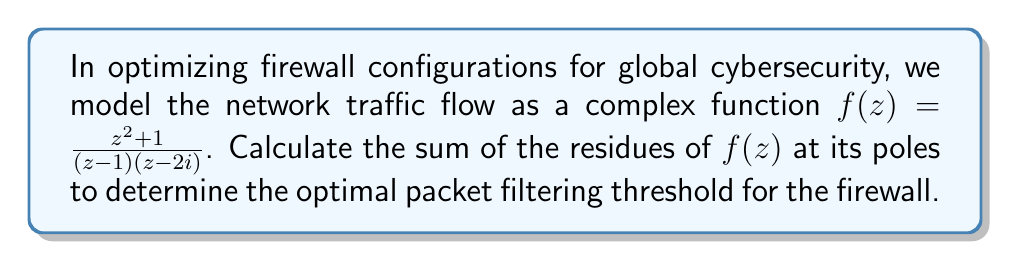Show me your answer to this math problem. To solve this problem, we need to follow these steps:

1) First, identify the poles of the function. The poles are at $z=1$ and $z=2i$.

2) To calculate the residues, we'll use the formula for simple poles:
   $\text{Res}(f,a) = \lim_{z \to a} (z-a)f(z)$

3) For the pole at $z=1$:
   $$\begin{aligned}
   \text{Res}(f,1) &= \lim_{z \to 1} (z-1)\frac{z^2 + 1}{(z-1)(z-2i)} \\
   &= \lim_{z \to 1} \frac{z^2 + 1}{z-2i} \\
   &= \frac{1^2 + 1}{1-2i} \\
   &= \frac{2}{1-2i} \\
   &= \frac{2(1+2i)}{1^2+4} \\
   &= \frac{2+4i}{5}
   \end{aligned}$$

4) For the pole at $z=2i$:
   $$\begin{aligned}
   \text{Res}(f,2i) &= \lim_{z \to 2i} (z-2i)\frac{z^2 + 1}{(z-1)(z-2i)} \\
   &= \lim_{z \to 2i} \frac{z^2 + 1}{z-1} \\
   &= \frac{(2i)^2 + 1}{2i-1} \\
   &= \frac{-3}{2i-1} \\
   &= \frac{-3(2i+1)}{(2i-1)(2i+1)} \\
   &= \frac{-6i-3}{5} \\
   &= \frac{-3-6i}{5}
   \end{aligned}$$

5) The sum of the residues is:
   $$\begin{aligned}
   \text{Sum} &= \frac{2+4i}{5} + \frac{-3-6i}{5} \\
   &= \frac{2+4i-3-6i}{5} \\
   &= \frac{-1-2i}{5}
   \end{aligned}$$

This sum represents the optimal packet filtering threshold for the firewall configuration.
Answer: $\frac{-1-2i}{5}$ 